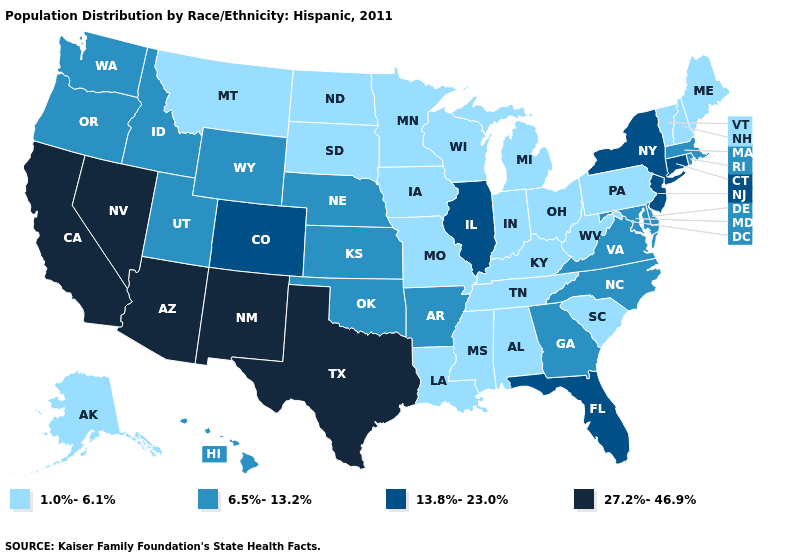Which states have the lowest value in the USA?
Keep it brief. Alabama, Alaska, Indiana, Iowa, Kentucky, Louisiana, Maine, Michigan, Minnesota, Mississippi, Missouri, Montana, New Hampshire, North Dakota, Ohio, Pennsylvania, South Carolina, South Dakota, Tennessee, Vermont, West Virginia, Wisconsin. What is the value of Pennsylvania?
Quick response, please. 1.0%-6.1%. What is the value of California?
Quick response, please. 27.2%-46.9%. What is the lowest value in states that border Arkansas?
Give a very brief answer. 1.0%-6.1%. Name the states that have a value in the range 6.5%-13.2%?
Answer briefly. Arkansas, Delaware, Georgia, Hawaii, Idaho, Kansas, Maryland, Massachusetts, Nebraska, North Carolina, Oklahoma, Oregon, Rhode Island, Utah, Virginia, Washington, Wyoming. What is the value of Arizona?
Answer briefly. 27.2%-46.9%. Name the states that have a value in the range 27.2%-46.9%?
Write a very short answer. Arizona, California, Nevada, New Mexico, Texas. Among the states that border West Virginia , does Kentucky have the highest value?
Concise answer only. No. Does Nebraska have a higher value than Delaware?
Keep it brief. No. Does the map have missing data?
Give a very brief answer. No. Which states hav the highest value in the West?
Write a very short answer. Arizona, California, Nevada, New Mexico. What is the value of South Dakota?
Be succinct. 1.0%-6.1%. What is the highest value in the South ?
Concise answer only. 27.2%-46.9%. Name the states that have a value in the range 27.2%-46.9%?
Give a very brief answer. Arizona, California, Nevada, New Mexico, Texas. Does Arkansas have a lower value than New Jersey?
Concise answer only. Yes. 